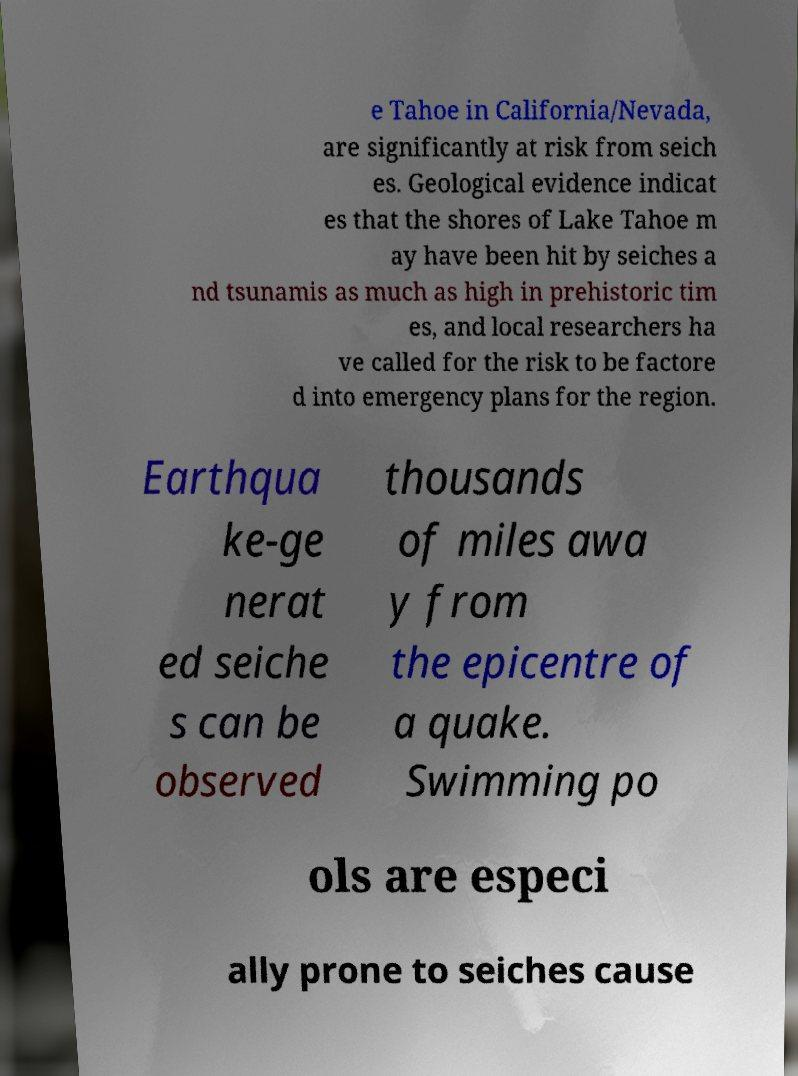Can you accurately transcribe the text from the provided image for me? e Tahoe in California/Nevada, are significantly at risk from seich es. Geological evidence indicat es that the shores of Lake Tahoe m ay have been hit by seiches a nd tsunamis as much as high in prehistoric tim es, and local researchers ha ve called for the risk to be factore d into emergency plans for the region. Earthqua ke-ge nerat ed seiche s can be observed thousands of miles awa y from the epicentre of a quake. Swimming po ols are especi ally prone to seiches cause 